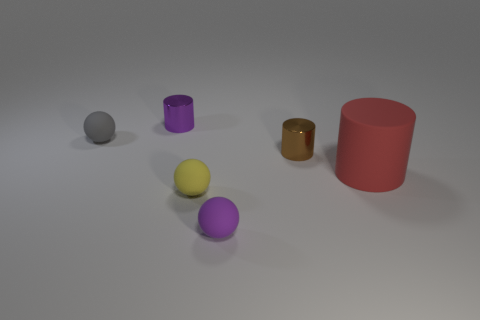What size is the rubber object that is behind the large cylinder?
Keep it short and to the point. Small. Is there anything else that is made of the same material as the yellow thing?
Offer a terse response. Yes. What number of matte balls are there?
Keep it short and to the point. 3. There is a rubber thing that is right of the small yellow rubber thing and in front of the large red cylinder; what color is it?
Ensure brevity in your answer.  Purple. Are there any large red rubber objects in front of the yellow matte thing?
Keep it short and to the point. No. There is a purple object that is in front of the small yellow rubber thing; what number of rubber things are behind it?
Provide a succinct answer. 3. What is the size of the other gray thing that is the same material as the big object?
Your answer should be very brief. Small. The gray ball has what size?
Keep it short and to the point. Small. Is the material of the brown cylinder the same as the small yellow object?
Your answer should be compact. No. How many balls are either small purple metallic objects or tiny metal objects?
Ensure brevity in your answer.  0. 